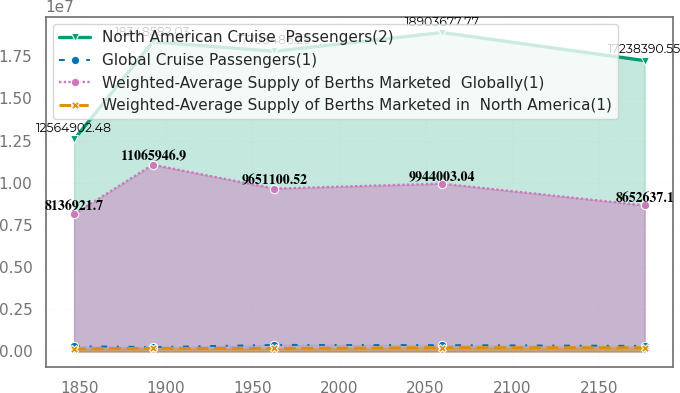Convert chart to OTSL. <chart><loc_0><loc_0><loc_500><loc_500><line_chart><ecel><fcel>North American Cruise  Passengers(2)<fcel>Global Cruise Passengers(1)<fcel>Weighted-Average Supply of Berths Marketed  Globally(1)<fcel>Weighted-Average Supply of Berths Marketed in  North America(1)<nl><fcel>1846.97<fcel>1.25649e+07<fcel>314127<fcel>8.13692e+06<fcel>157727<nl><fcel>1892.35<fcel>1.83486e+07<fcel>255891<fcel>1.10659e+07<fcel>181511<nl><fcel>1962.62<fcel>1.77935e+07<fcel>387326<fcel>9.6511e+06<fcel>175290<nl><fcel>2059.49<fcel>1.89037e+07<fcel>374268<fcel>9.944e+06<fcel>222070<nl><fcel>2176.5<fcel>1.72384e+07<fcel>327185<fcel>8.65264e+06<fcel>215849<nl></chart> 